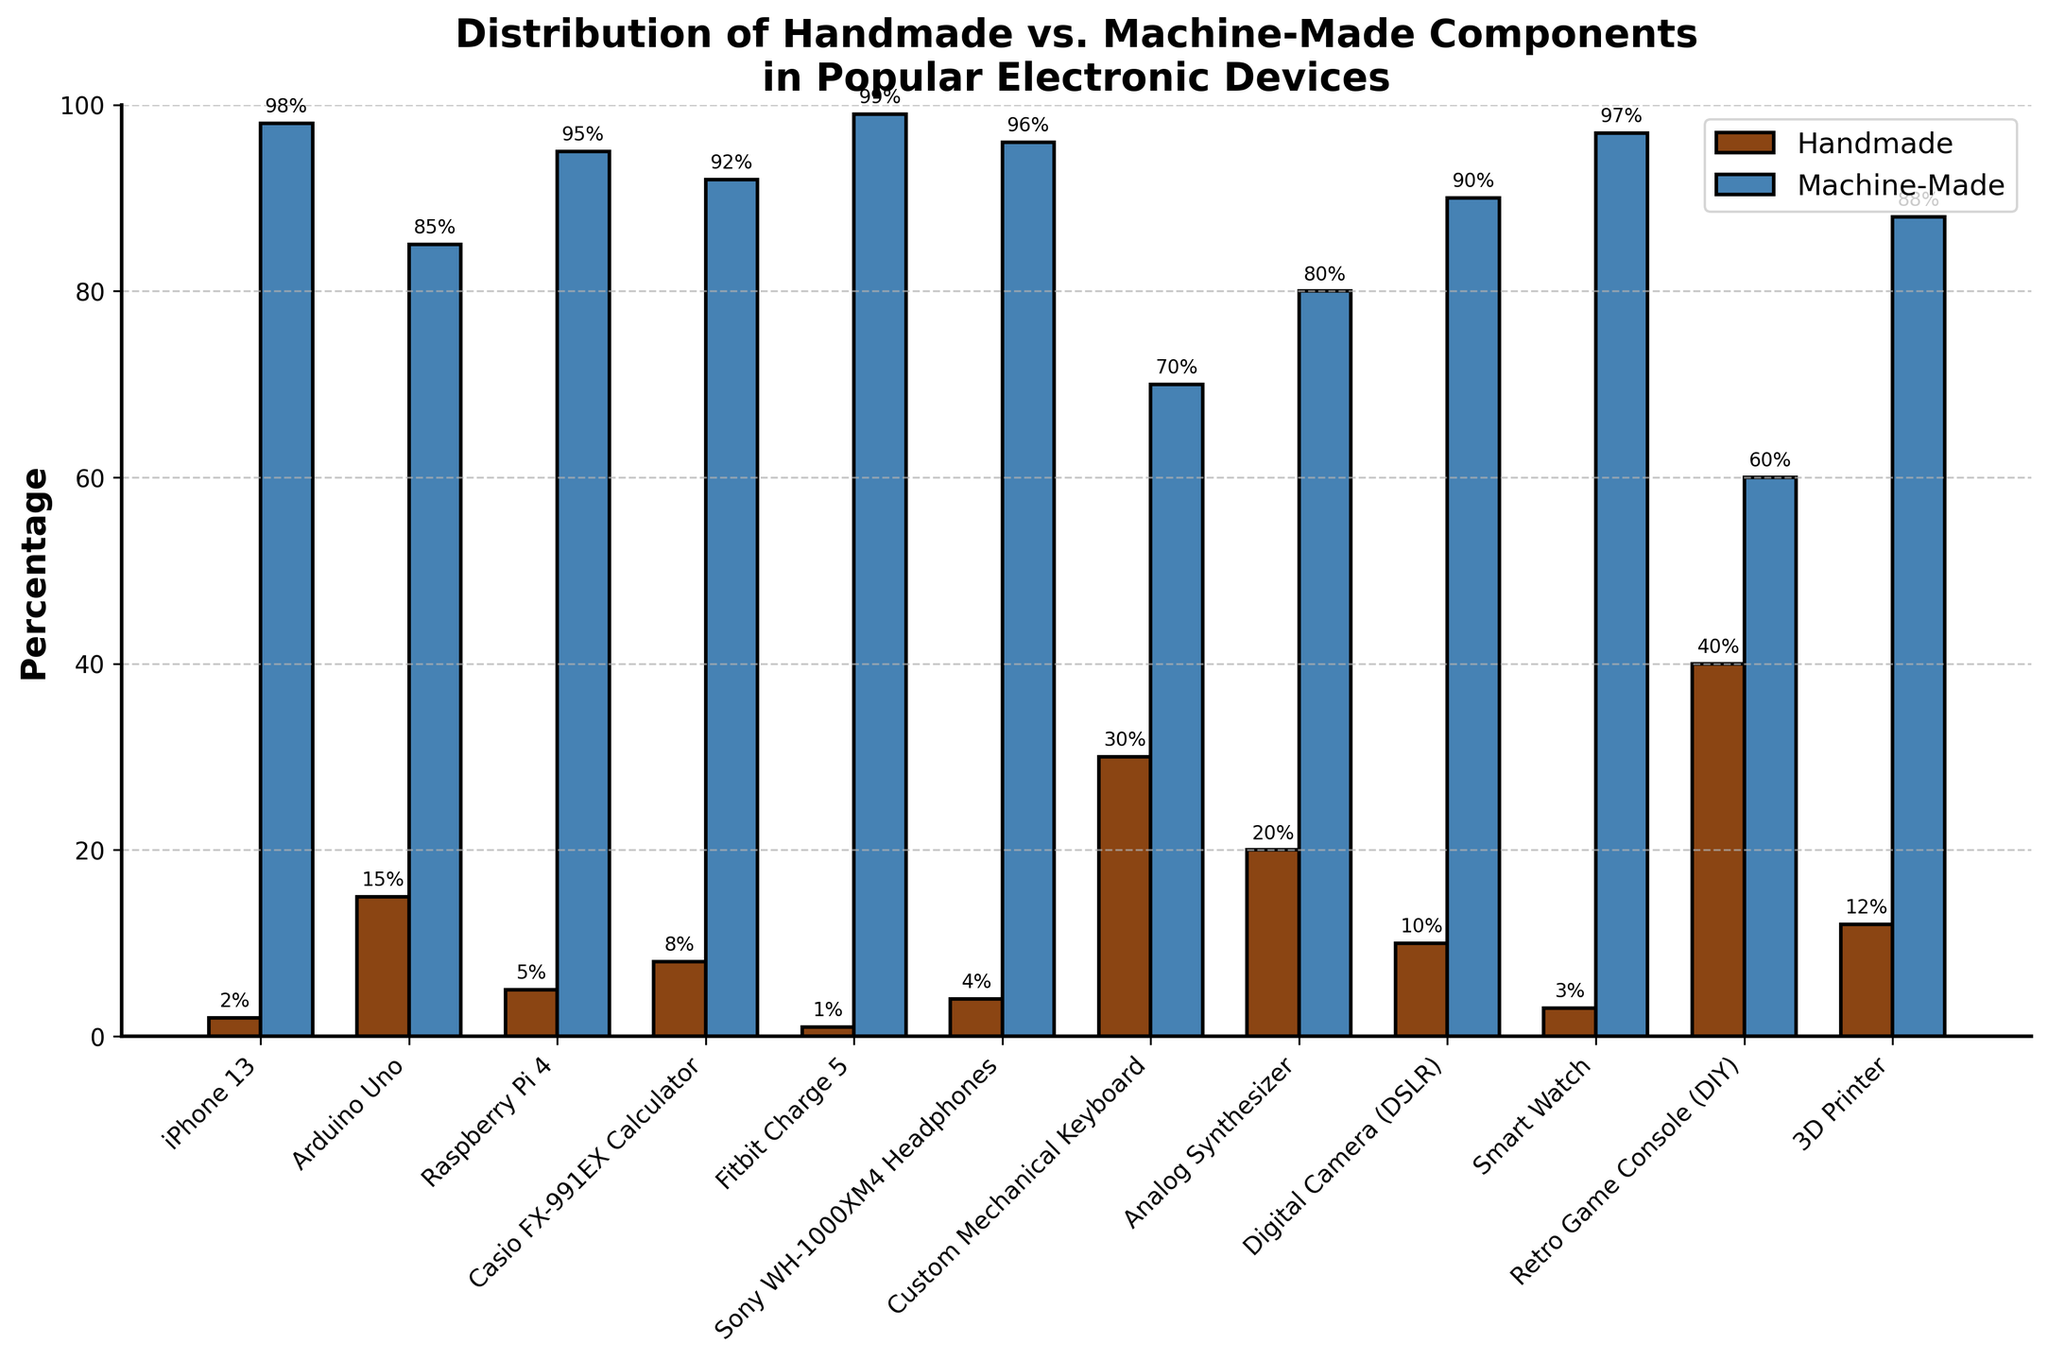What's the device with the highest percentage of handmade components? The device with the highest bar segment for handmade components is the Retro Game Console (DIY).
Answer: Retro Game Console (DIY) Which device has the smallest proportion of handmade components? The device with the smallest bar segment for handmade components is the Fitbit Charge 5.
Answer: Fitbit Charge 5 Compare the handmade components percentage of the Arduino Uno and the Raspberry Pi 4. Which one has more? The bar for handmade components in the Arduino Uno is higher at 15% compared to the Raspberry Pi 4 at 5%.
Answer: Arduino Uno What’s the combined percentage of handmade components for the iPhone 13 and the Digital Camera (DSLR)? The iPhone 13 has a handmade components percentage of 2%, and the Digital Camera (DSLR) has 10%. Adding them together, 2% + 10% = 12%.
Answer: 12% Which device out of the Custom Mechanical Keyboard and Analog Synthesizer has a higher percentage of machine-made components, and by how much? The Custom Mechanical Keyboard has 70% machine-made components and the Analog Synthesizer has 80%. The difference is 80% - 70% = 10%.
Answer: Analog Synthesizer by 10% Identify the device that shows an equal difference between handmade and machine-made components percentages. If we look at the graphical representation, the Retro Game Console (DIY) has 40% handmade and 60% machine-made, showing a difference of 20% each.
Answer: Retro Game Console (DIY) What is the ratio of handmade to machine-made components for the Sony WH-1000XM4 Headphones? For Sony WH-1000XM4 Headphones, the percentage of handmade components is 4%, and machine-made is 96%. The ratio can be calculated as 4:96, which simplifies to 1:24.
Answer: 1:24 Which device has the closest proportion of handmade to machine-made components being 15% and 85%, respectively? The Arduino Uno has a 15% handmade and 85% machine-made components distribution, matching the required proportions.
Answer: Arduino Uno How does the percentage of handmade components in the Casio FX-991EX Calculator compare with that in a 3D Printer? The Casio FX-991EX Calculator has 8% handmade components, while a 3D Printer has 12%. The difference is 12% - 8% = 4%.
Answer: 3D Printer by 4% Calculate the total percentage of machine-made components for the Smart Watch, iPhone 13, and Fitbit Charge 5. The machine-made components percentages are 97% for Smart Watch, 98% for iPhone 13, and 99% for Fitbit Charge 5. Adding them, 97% + 98% + 99% = 294%.
Answer: 294% 